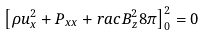<formula> <loc_0><loc_0><loc_500><loc_500>\left [ \rho u _ { x } ^ { 2 } + P _ { x x } + r a c { B _ { z } ^ { 2 } } { 8 \pi } \right ] ^ { 2 } _ { 0 } = 0</formula> 